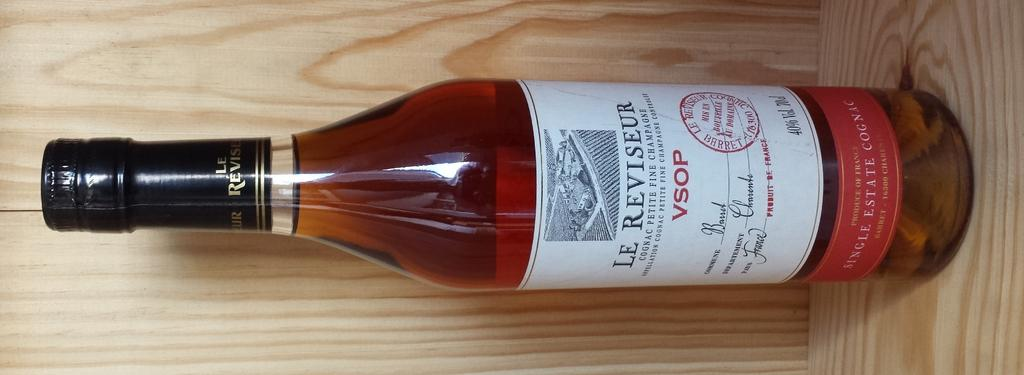<image>
Write a terse but informative summary of the picture. A bottle of Le Reviseur cognac on a shelf 